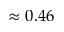Convert formula to latex. <formula><loc_0><loc_0><loc_500><loc_500>\approx 0 . 4 6</formula> 